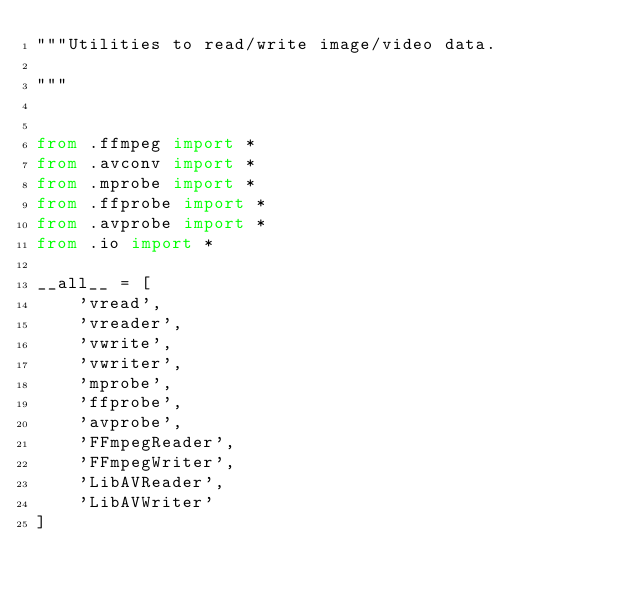Convert code to text. <code><loc_0><loc_0><loc_500><loc_500><_Python_>"""Utilities to read/write image/video data.

"""


from .ffmpeg import *
from .avconv import *
from .mprobe import *
from .ffprobe import *
from .avprobe import *
from .io import *

__all__ = [
    'vread',
    'vreader',
    'vwrite',
    'vwriter',
    'mprobe',
    'ffprobe',
    'avprobe',
    'FFmpegReader',
    'FFmpegWriter',
    'LibAVReader',
    'LibAVWriter'
]
</code> 